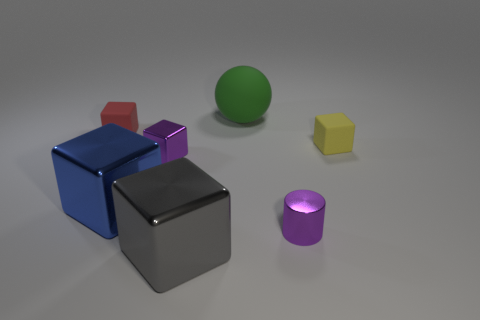How many shiny things are yellow things or tiny red blocks?
Give a very brief answer. 0. Does the large block that is behind the gray metal object have the same material as the big thing behind the red thing?
Provide a short and direct response. No. Are there any small purple things?
Make the answer very short. Yes. Do the small rubber object to the right of the large blue cube and the small matte thing to the left of the yellow cube have the same shape?
Offer a terse response. Yes. Is there a red cube made of the same material as the tiny red object?
Provide a short and direct response. No. Is the blue cube that is to the left of the small yellow matte block made of the same material as the small purple cube?
Provide a short and direct response. Yes. Is the number of large green rubber balls behind the green rubber ball greater than the number of blue cubes to the right of the tiny yellow thing?
Offer a terse response. No. The shiny cube that is the same size as the yellow matte thing is what color?
Provide a succinct answer. Purple. Is there a cube of the same color as the small metal cylinder?
Offer a very short reply. Yes. Does the small rubber object to the right of the gray block have the same color as the thing that is behind the tiny red rubber cube?
Your answer should be very brief. No. 